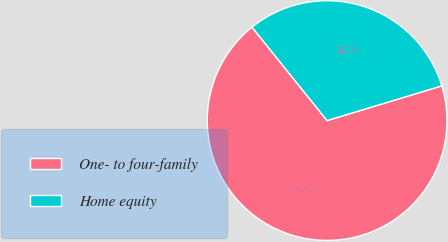<chart> <loc_0><loc_0><loc_500><loc_500><pie_chart><fcel>One- to four-family<fcel>Home equity<nl><fcel>68.9%<fcel>31.1%<nl></chart> 